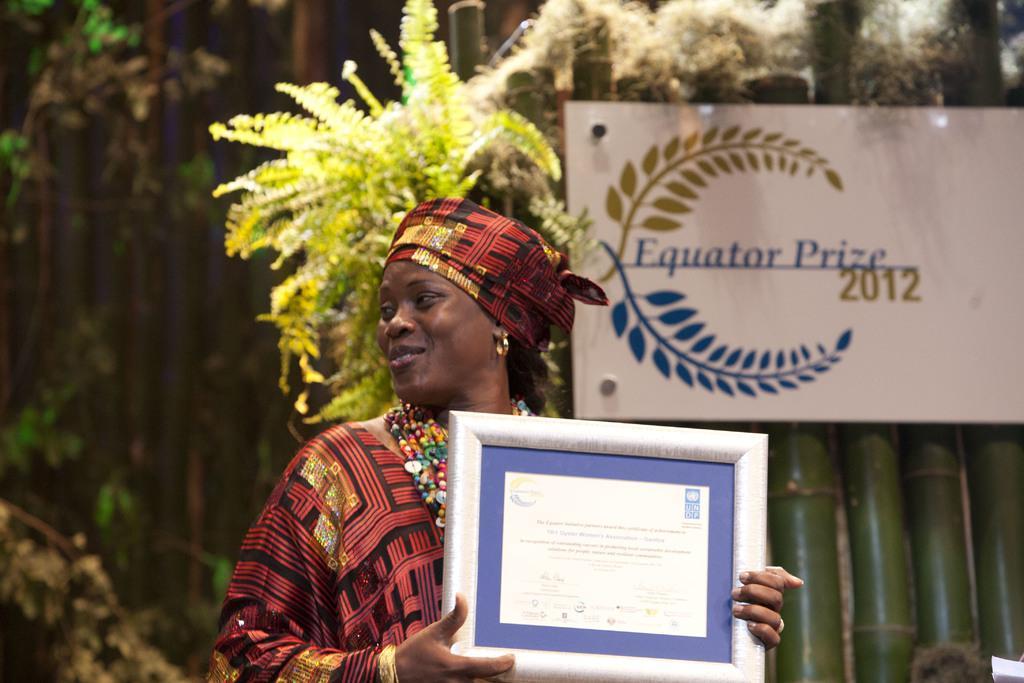Can you describe this image briefly? In this image I can see a woman is holding a frame in hands and smiling by looking at the left side. in the background I can see a wall which is made up of the bamboo sticks. To this wall I can see a white color board is attached. At the back of this woman I can see some plants. 